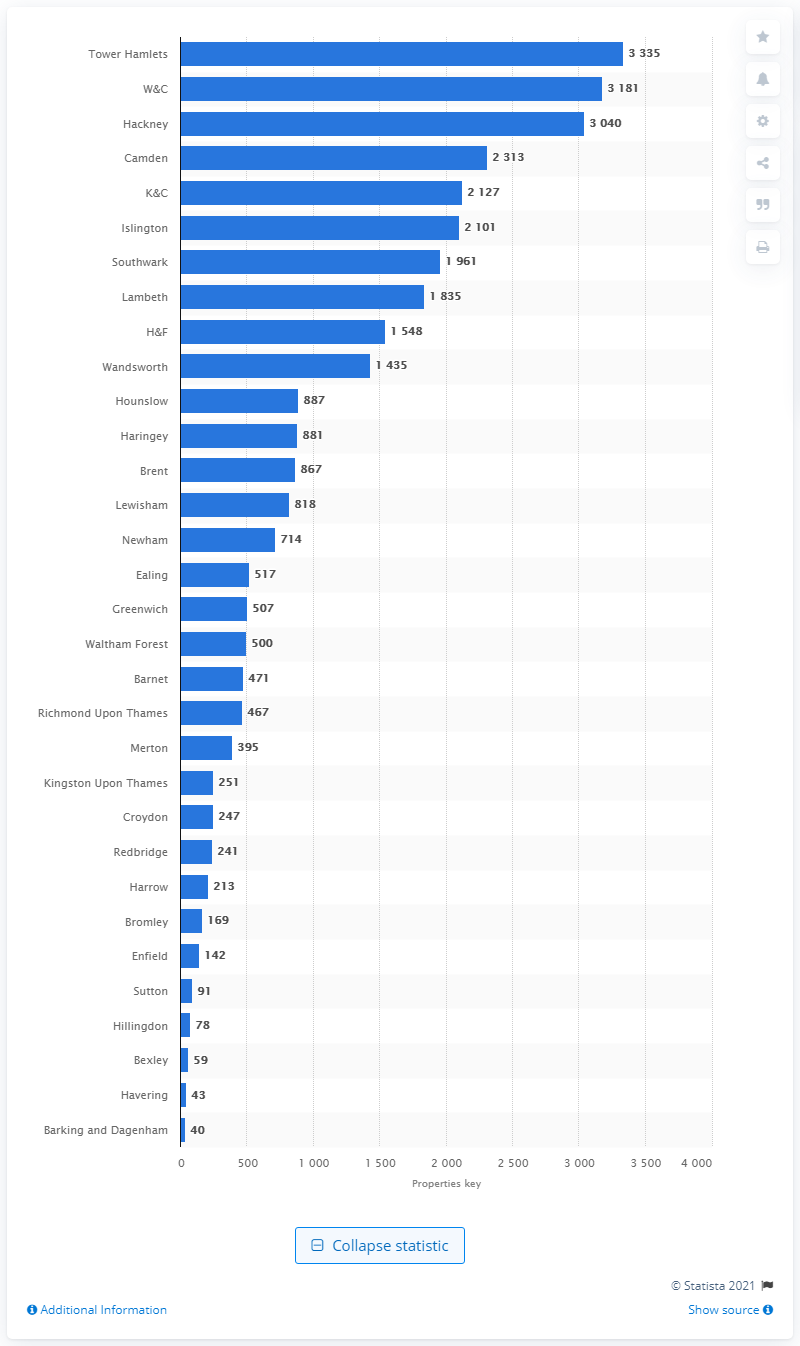Draw attention to some important aspects in this diagram. According to data, Tower Hamlets is the borough with the highest number of Airbnb listings in London. 